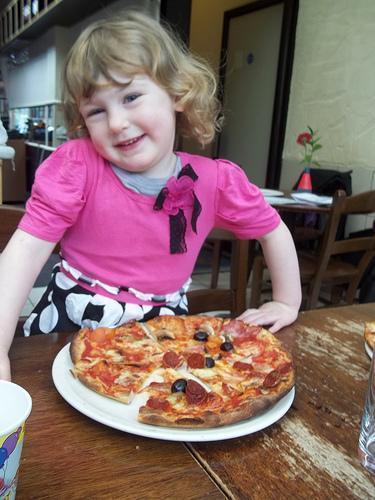How many people are in the picture?
Give a very brief answer. 1. 